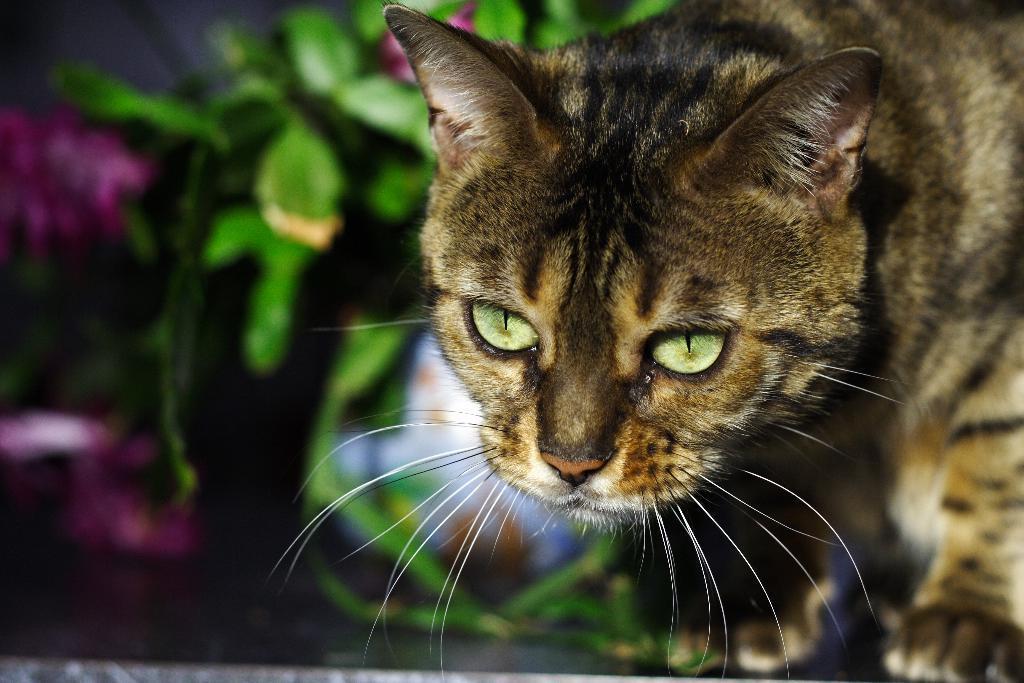Describe this image in one or two sentences. In this image, we can see a cat and we can see some green leaves. 